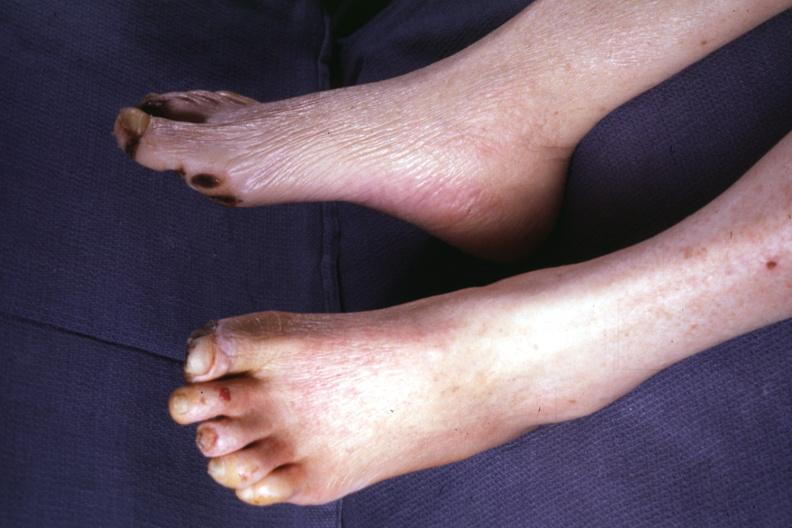what are present?
Answer the question using a single word or phrase. Extremities 